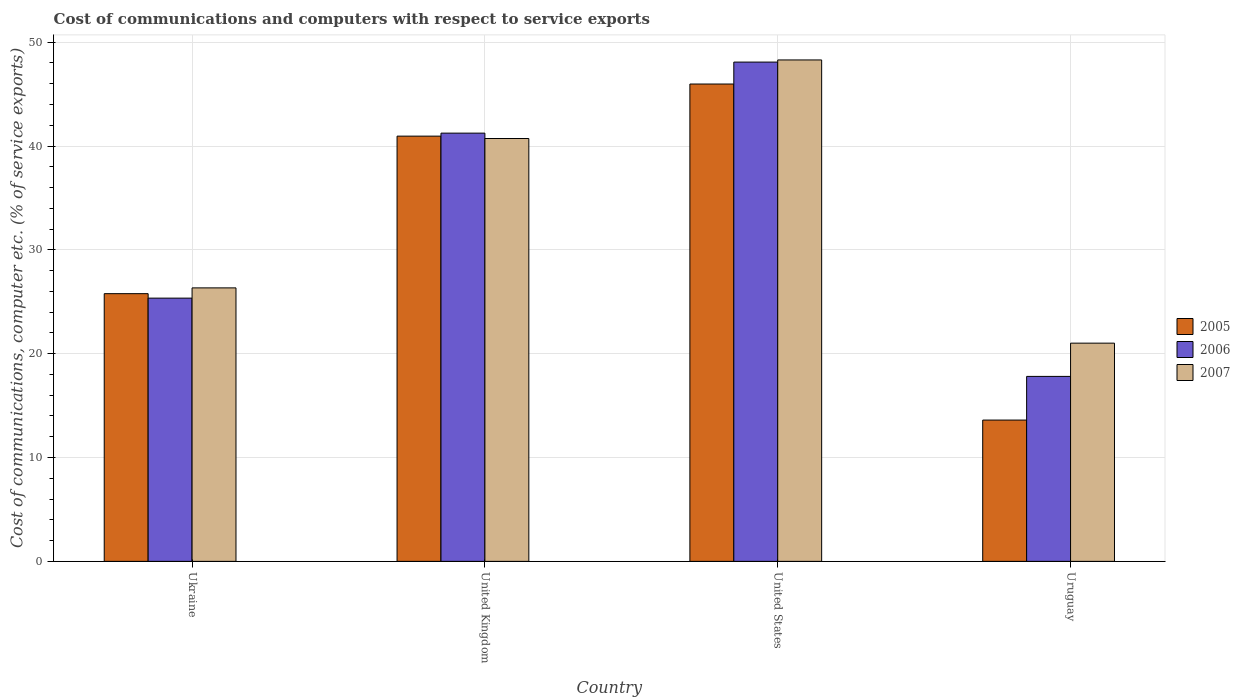How many different coloured bars are there?
Your answer should be compact. 3. How many groups of bars are there?
Your response must be concise. 4. Are the number of bars per tick equal to the number of legend labels?
Provide a short and direct response. Yes. Are the number of bars on each tick of the X-axis equal?
Keep it short and to the point. Yes. How many bars are there on the 1st tick from the left?
Provide a succinct answer. 3. How many bars are there on the 1st tick from the right?
Your answer should be compact. 3. What is the label of the 4th group of bars from the left?
Your answer should be very brief. Uruguay. In how many cases, is the number of bars for a given country not equal to the number of legend labels?
Give a very brief answer. 0. What is the cost of communications and computers in 2007 in Ukraine?
Ensure brevity in your answer.  26.34. Across all countries, what is the maximum cost of communications and computers in 2005?
Provide a short and direct response. 45.97. Across all countries, what is the minimum cost of communications and computers in 2007?
Keep it short and to the point. 21.01. In which country was the cost of communications and computers in 2006 maximum?
Offer a terse response. United States. In which country was the cost of communications and computers in 2005 minimum?
Your answer should be very brief. Uruguay. What is the total cost of communications and computers in 2005 in the graph?
Give a very brief answer. 126.31. What is the difference between the cost of communications and computers in 2007 in United States and that in Uruguay?
Keep it short and to the point. 27.27. What is the difference between the cost of communications and computers in 2007 in Uruguay and the cost of communications and computers in 2005 in Ukraine?
Your answer should be very brief. -4.77. What is the average cost of communications and computers in 2005 per country?
Your answer should be very brief. 31.58. What is the difference between the cost of communications and computers of/in 2007 and cost of communications and computers of/in 2005 in Ukraine?
Offer a terse response. 0.56. In how many countries, is the cost of communications and computers in 2005 greater than 4 %?
Your response must be concise. 4. What is the ratio of the cost of communications and computers in 2007 in United States to that in Uruguay?
Provide a succinct answer. 2.3. Is the cost of communications and computers in 2005 in Ukraine less than that in United States?
Offer a very short reply. Yes. Is the difference between the cost of communications and computers in 2007 in Ukraine and United Kingdom greater than the difference between the cost of communications and computers in 2005 in Ukraine and United Kingdom?
Offer a terse response. Yes. What is the difference between the highest and the second highest cost of communications and computers in 2005?
Provide a succinct answer. 15.17. What is the difference between the highest and the lowest cost of communications and computers in 2005?
Provide a succinct answer. 32.36. In how many countries, is the cost of communications and computers in 2006 greater than the average cost of communications and computers in 2006 taken over all countries?
Offer a very short reply. 2. What does the 3rd bar from the left in United States represents?
Your answer should be compact. 2007. How many bars are there?
Your response must be concise. 12. Does the graph contain any zero values?
Your answer should be very brief. No. Does the graph contain grids?
Offer a terse response. Yes. How are the legend labels stacked?
Your answer should be very brief. Vertical. What is the title of the graph?
Your answer should be very brief. Cost of communications and computers with respect to service exports. Does "1985" appear as one of the legend labels in the graph?
Offer a very short reply. No. What is the label or title of the X-axis?
Keep it short and to the point. Country. What is the label or title of the Y-axis?
Offer a terse response. Cost of communications, computer etc. (% of service exports). What is the Cost of communications, computer etc. (% of service exports) in 2005 in Ukraine?
Your response must be concise. 25.78. What is the Cost of communications, computer etc. (% of service exports) in 2006 in Ukraine?
Offer a very short reply. 25.35. What is the Cost of communications, computer etc. (% of service exports) in 2007 in Ukraine?
Make the answer very short. 26.34. What is the Cost of communications, computer etc. (% of service exports) of 2005 in United Kingdom?
Your answer should be very brief. 40.95. What is the Cost of communications, computer etc. (% of service exports) of 2006 in United Kingdom?
Your answer should be compact. 41.24. What is the Cost of communications, computer etc. (% of service exports) in 2007 in United Kingdom?
Keep it short and to the point. 40.72. What is the Cost of communications, computer etc. (% of service exports) of 2005 in United States?
Offer a very short reply. 45.97. What is the Cost of communications, computer etc. (% of service exports) in 2006 in United States?
Ensure brevity in your answer.  48.08. What is the Cost of communications, computer etc. (% of service exports) of 2007 in United States?
Give a very brief answer. 48.29. What is the Cost of communications, computer etc. (% of service exports) of 2005 in Uruguay?
Provide a succinct answer. 13.61. What is the Cost of communications, computer etc. (% of service exports) of 2006 in Uruguay?
Your answer should be compact. 17.81. What is the Cost of communications, computer etc. (% of service exports) in 2007 in Uruguay?
Provide a short and direct response. 21.01. Across all countries, what is the maximum Cost of communications, computer etc. (% of service exports) of 2005?
Provide a succinct answer. 45.97. Across all countries, what is the maximum Cost of communications, computer etc. (% of service exports) in 2006?
Provide a succinct answer. 48.08. Across all countries, what is the maximum Cost of communications, computer etc. (% of service exports) of 2007?
Offer a terse response. 48.29. Across all countries, what is the minimum Cost of communications, computer etc. (% of service exports) of 2005?
Give a very brief answer. 13.61. Across all countries, what is the minimum Cost of communications, computer etc. (% of service exports) in 2006?
Give a very brief answer. 17.81. Across all countries, what is the minimum Cost of communications, computer etc. (% of service exports) in 2007?
Offer a very short reply. 21.01. What is the total Cost of communications, computer etc. (% of service exports) in 2005 in the graph?
Your answer should be compact. 126.31. What is the total Cost of communications, computer etc. (% of service exports) of 2006 in the graph?
Keep it short and to the point. 132.49. What is the total Cost of communications, computer etc. (% of service exports) of 2007 in the graph?
Offer a very short reply. 136.37. What is the difference between the Cost of communications, computer etc. (% of service exports) in 2005 in Ukraine and that in United Kingdom?
Make the answer very short. -15.17. What is the difference between the Cost of communications, computer etc. (% of service exports) in 2006 in Ukraine and that in United Kingdom?
Ensure brevity in your answer.  -15.89. What is the difference between the Cost of communications, computer etc. (% of service exports) of 2007 in Ukraine and that in United Kingdom?
Keep it short and to the point. -14.39. What is the difference between the Cost of communications, computer etc. (% of service exports) of 2005 in Ukraine and that in United States?
Your answer should be compact. -20.19. What is the difference between the Cost of communications, computer etc. (% of service exports) in 2006 in Ukraine and that in United States?
Give a very brief answer. -22.73. What is the difference between the Cost of communications, computer etc. (% of service exports) of 2007 in Ukraine and that in United States?
Keep it short and to the point. -21.95. What is the difference between the Cost of communications, computer etc. (% of service exports) in 2005 in Ukraine and that in Uruguay?
Your answer should be very brief. 12.17. What is the difference between the Cost of communications, computer etc. (% of service exports) of 2006 in Ukraine and that in Uruguay?
Provide a short and direct response. 7.54. What is the difference between the Cost of communications, computer etc. (% of service exports) of 2007 in Ukraine and that in Uruguay?
Provide a succinct answer. 5.32. What is the difference between the Cost of communications, computer etc. (% of service exports) of 2005 in United Kingdom and that in United States?
Offer a terse response. -5.02. What is the difference between the Cost of communications, computer etc. (% of service exports) of 2006 in United Kingdom and that in United States?
Your response must be concise. -6.84. What is the difference between the Cost of communications, computer etc. (% of service exports) of 2007 in United Kingdom and that in United States?
Provide a short and direct response. -7.57. What is the difference between the Cost of communications, computer etc. (% of service exports) in 2005 in United Kingdom and that in Uruguay?
Offer a terse response. 27.34. What is the difference between the Cost of communications, computer etc. (% of service exports) of 2006 in United Kingdom and that in Uruguay?
Your answer should be very brief. 23.43. What is the difference between the Cost of communications, computer etc. (% of service exports) of 2007 in United Kingdom and that in Uruguay?
Provide a succinct answer. 19.71. What is the difference between the Cost of communications, computer etc. (% of service exports) in 2005 in United States and that in Uruguay?
Keep it short and to the point. 32.36. What is the difference between the Cost of communications, computer etc. (% of service exports) of 2006 in United States and that in Uruguay?
Offer a terse response. 30.27. What is the difference between the Cost of communications, computer etc. (% of service exports) in 2007 in United States and that in Uruguay?
Your answer should be very brief. 27.27. What is the difference between the Cost of communications, computer etc. (% of service exports) in 2005 in Ukraine and the Cost of communications, computer etc. (% of service exports) in 2006 in United Kingdom?
Give a very brief answer. -15.46. What is the difference between the Cost of communications, computer etc. (% of service exports) of 2005 in Ukraine and the Cost of communications, computer etc. (% of service exports) of 2007 in United Kingdom?
Offer a terse response. -14.94. What is the difference between the Cost of communications, computer etc. (% of service exports) of 2006 in Ukraine and the Cost of communications, computer etc. (% of service exports) of 2007 in United Kingdom?
Provide a succinct answer. -15.37. What is the difference between the Cost of communications, computer etc. (% of service exports) in 2005 in Ukraine and the Cost of communications, computer etc. (% of service exports) in 2006 in United States?
Offer a terse response. -22.3. What is the difference between the Cost of communications, computer etc. (% of service exports) of 2005 in Ukraine and the Cost of communications, computer etc. (% of service exports) of 2007 in United States?
Provide a succinct answer. -22.51. What is the difference between the Cost of communications, computer etc. (% of service exports) in 2006 in Ukraine and the Cost of communications, computer etc. (% of service exports) in 2007 in United States?
Offer a very short reply. -22.94. What is the difference between the Cost of communications, computer etc. (% of service exports) of 2005 in Ukraine and the Cost of communications, computer etc. (% of service exports) of 2006 in Uruguay?
Ensure brevity in your answer.  7.97. What is the difference between the Cost of communications, computer etc. (% of service exports) in 2005 in Ukraine and the Cost of communications, computer etc. (% of service exports) in 2007 in Uruguay?
Your answer should be compact. 4.77. What is the difference between the Cost of communications, computer etc. (% of service exports) in 2006 in Ukraine and the Cost of communications, computer etc. (% of service exports) in 2007 in Uruguay?
Ensure brevity in your answer.  4.34. What is the difference between the Cost of communications, computer etc. (% of service exports) of 2005 in United Kingdom and the Cost of communications, computer etc. (% of service exports) of 2006 in United States?
Offer a terse response. -7.13. What is the difference between the Cost of communications, computer etc. (% of service exports) in 2005 in United Kingdom and the Cost of communications, computer etc. (% of service exports) in 2007 in United States?
Keep it short and to the point. -7.34. What is the difference between the Cost of communications, computer etc. (% of service exports) of 2006 in United Kingdom and the Cost of communications, computer etc. (% of service exports) of 2007 in United States?
Give a very brief answer. -7.05. What is the difference between the Cost of communications, computer etc. (% of service exports) in 2005 in United Kingdom and the Cost of communications, computer etc. (% of service exports) in 2006 in Uruguay?
Your answer should be compact. 23.14. What is the difference between the Cost of communications, computer etc. (% of service exports) in 2005 in United Kingdom and the Cost of communications, computer etc. (% of service exports) in 2007 in Uruguay?
Offer a terse response. 19.94. What is the difference between the Cost of communications, computer etc. (% of service exports) in 2006 in United Kingdom and the Cost of communications, computer etc. (% of service exports) in 2007 in Uruguay?
Provide a succinct answer. 20.23. What is the difference between the Cost of communications, computer etc. (% of service exports) in 2005 in United States and the Cost of communications, computer etc. (% of service exports) in 2006 in Uruguay?
Make the answer very short. 28.16. What is the difference between the Cost of communications, computer etc. (% of service exports) of 2005 in United States and the Cost of communications, computer etc. (% of service exports) of 2007 in Uruguay?
Provide a short and direct response. 24.96. What is the difference between the Cost of communications, computer etc. (% of service exports) in 2006 in United States and the Cost of communications, computer etc. (% of service exports) in 2007 in Uruguay?
Provide a short and direct response. 27.07. What is the average Cost of communications, computer etc. (% of service exports) of 2005 per country?
Ensure brevity in your answer.  31.58. What is the average Cost of communications, computer etc. (% of service exports) in 2006 per country?
Give a very brief answer. 33.12. What is the average Cost of communications, computer etc. (% of service exports) of 2007 per country?
Your answer should be compact. 34.09. What is the difference between the Cost of communications, computer etc. (% of service exports) of 2005 and Cost of communications, computer etc. (% of service exports) of 2006 in Ukraine?
Provide a succinct answer. 0.43. What is the difference between the Cost of communications, computer etc. (% of service exports) in 2005 and Cost of communications, computer etc. (% of service exports) in 2007 in Ukraine?
Give a very brief answer. -0.56. What is the difference between the Cost of communications, computer etc. (% of service exports) in 2006 and Cost of communications, computer etc. (% of service exports) in 2007 in Ukraine?
Your answer should be compact. -0.99. What is the difference between the Cost of communications, computer etc. (% of service exports) of 2005 and Cost of communications, computer etc. (% of service exports) of 2006 in United Kingdom?
Offer a very short reply. -0.29. What is the difference between the Cost of communications, computer etc. (% of service exports) of 2005 and Cost of communications, computer etc. (% of service exports) of 2007 in United Kingdom?
Offer a very short reply. 0.23. What is the difference between the Cost of communications, computer etc. (% of service exports) of 2006 and Cost of communications, computer etc. (% of service exports) of 2007 in United Kingdom?
Ensure brevity in your answer.  0.52. What is the difference between the Cost of communications, computer etc. (% of service exports) in 2005 and Cost of communications, computer etc. (% of service exports) in 2006 in United States?
Give a very brief answer. -2.11. What is the difference between the Cost of communications, computer etc. (% of service exports) in 2005 and Cost of communications, computer etc. (% of service exports) in 2007 in United States?
Keep it short and to the point. -2.32. What is the difference between the Cost of communications, computer etc. (% of service exports) in 2006 and Cost of communications, computer etc. (% of service exports) in 2007 in United States?
Offer a terse response. -0.21. What is the difference between the Cost of communications, computer etc. (% of service exports) in 2005 and Cost of communications, computer etc. (% of service exports) in 2006 in Uruguay?
Provide a short and direct response. -4.21. What is the difference between the Cost of communications, computer etc. (% of service exports) of 2005 and Cost of communications, computer etc. (% of service exports) of 2007 in Uruguay?
Give a very brief answer. -7.41. What is the difference between the Cost of communications, computer etc. (% of service exports) in 2006 and Cost of communications, computer etc. (% of service exports) in 2007 in Uruguay?
Make the answer very short. -3.2. What is the ratio of the Cost of communications, computer etc. (% of service exports) of 2005 in Ukraine to that in United Kingdom?
Offer a terse response. 0.63. What is the ratio of the Cost of communications, computer etc. (% of service exports) of 2006 in Ukraine to that in United Kingdom?
Give a very brief answer. 0.61. What is the ratio of the Cost of communications, computer etc. (% of service exports) in 2007 in Ukraine to that in United Kingdom?
Your response must be concise. 0.65. What is the ratio of the Cost of communications, computer etc. (% of service exports) in 2005 in Ukraine to that in United States?
Your answer should be compact. 0.56. What is the ratio of the Cost of communications, computer etc. (% of service exports) of 2006 in Ukraine to that in United States?
Provide a succinct answer. 0.53. What is the ratio of the Cost of communications, computer etc. (% of service exports) in 2007 in Ukraine to that in United States?
Keep it short and to the point. 0.55. What is the ratio of the Cost of communications, computer etc. (% of service exports) in 2005 in Ukraine to that in Uruguay?
Provide a succinct answer. 1.89. What is the ratio of the Cost of communications, computer etc. (% of service exports) in 2006 in Ukraine to that in Uruguay?
Keep it short and to the point. 1.42. What is the ratio of the Cost of communications, computer etc. (% of service exports) of 2007 in Ukraine to that in Uruguay?
Give a very brief answer. 1.25. What is the ratio of the Cost of communications, computer etc. (% of service exports) of 2005 in United Kingdom to that in United States?
Your answer should be very brief. 0.89. What is the ratio of the Cost of communications, computer etc. (% of service exports) of 2006 in United Kingdom to that in United States?
Your answer should be very brief. 0.86. What is the ratio of the Cost of communications, computer etc. (% of service exports) of 2007 in United Kingdom to that in United States?
Make the answer very short. 0.84. What is the ratio of the Cost of communications, computer etc. (% of service exports) of 2005 in United Kingdom to that in Uruguay?
Your answer should be compact. 3.01. What is the ratio of the Cost of communications, computer etc. (% of service exports) of 2006 in United Kingdom to that in Uruguay?
Ensure brevity in your answer.  2.32. What is the ratio of the Cost of communications, computer etc. (% of service exports) in 2007 in United Kingdom to that in Uruguay?
Your answer should be very brief. 1.94. What is the ratio of the Cost of communications, computer etc. (% of service exports) in 2005 in United States to that in Uruguay?
Your answer should be very brief. 3.38. What is the ratio of the Cost of communications, computer etc. (% of service exports) of 2006 in United States to that in Uruguay?
Give a very brief answer. 2.7. What is the ratio of the Cost of communications, computer etc. (% of service exports) in 2007 in United States to that in Uruguay?
Your response must be concise. 2.3. What is the difference between the highest and the second highest Cost of communications, computer etc. (% of service exports) in 2005?
Your answer should be very brief. 5.02. What is the difference between the highest and the second highest Cost of communications, computer etc. (% of service exports) in 2006?
Keep it short and to the point. 6.84. What is the difference between the highest and the second highest Cost of communications, computer etc. (% of service exports) in 2007?
Your answer should be compact. 7.57. What is the difference between the highest and the lowest Cost of communications, computer etc. (% of service exports) in 2005?
Give a very brief answer. 32.36. What is the difference between the highest and the lowest Cost of communications, computer etc. (% of service exports) in 2006?
Offer a very short reply. 30.27. What is the difference between the highest and the lowest Cost of communications, computer etc. (% of service exports) in 2007?
Offer a terse response. 27.27. 